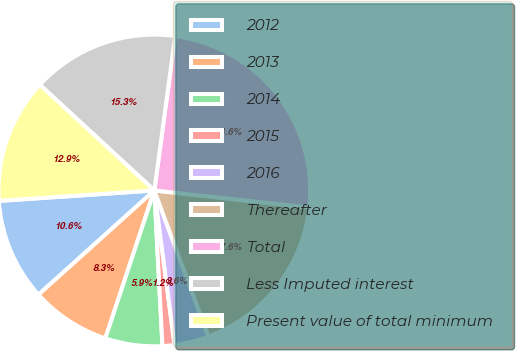Convert chart to OTSL. <chart><loc_0><loc_0><loc_500><loc_500><pie_chart><fcel>2012<fcel>2013<fcel>2014<fcel>2015<fcel>2016<fcel>Thereafter<fcel>Total<fcel>Less Imputed interest<fcel>Present value of total minimum<nl><fcel>10.59%<fcel>8.25%<fcel>5.92%<fcel>1.24%<fcel>3.58%<fcel>17.6%<fcel>24.61%<fcel>15.27%<fcel>12.93%<nl></chart> 